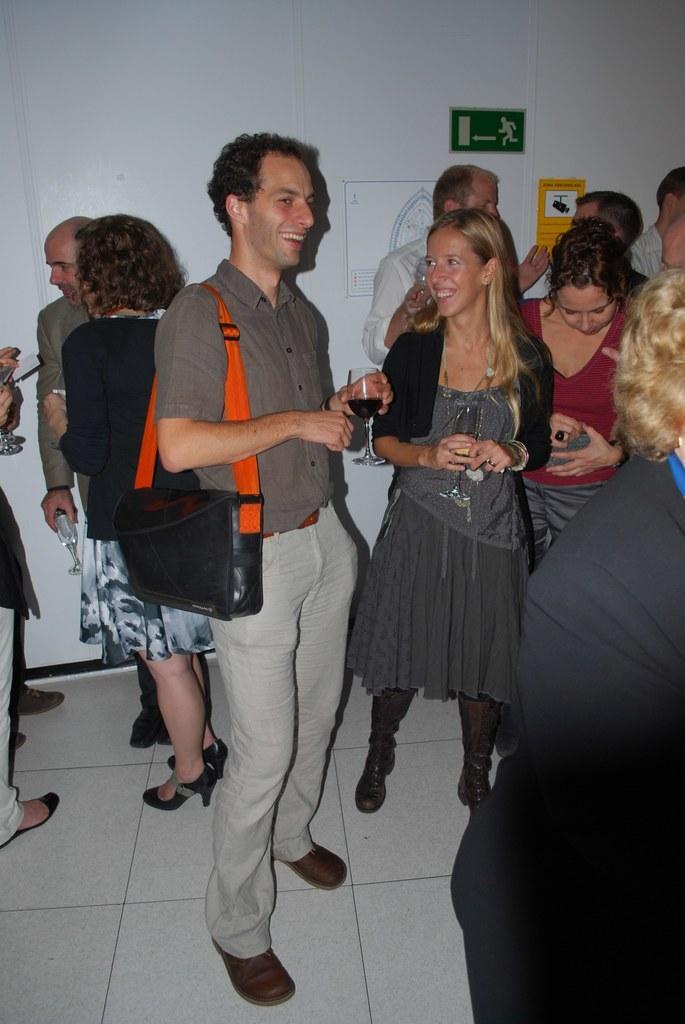Please provide a concise description of this image. In this image I can see the floor, number of persons standing on the floor, few persons holding glasses in their hands and the white colored wall. I can see few boards attached to the wall. 